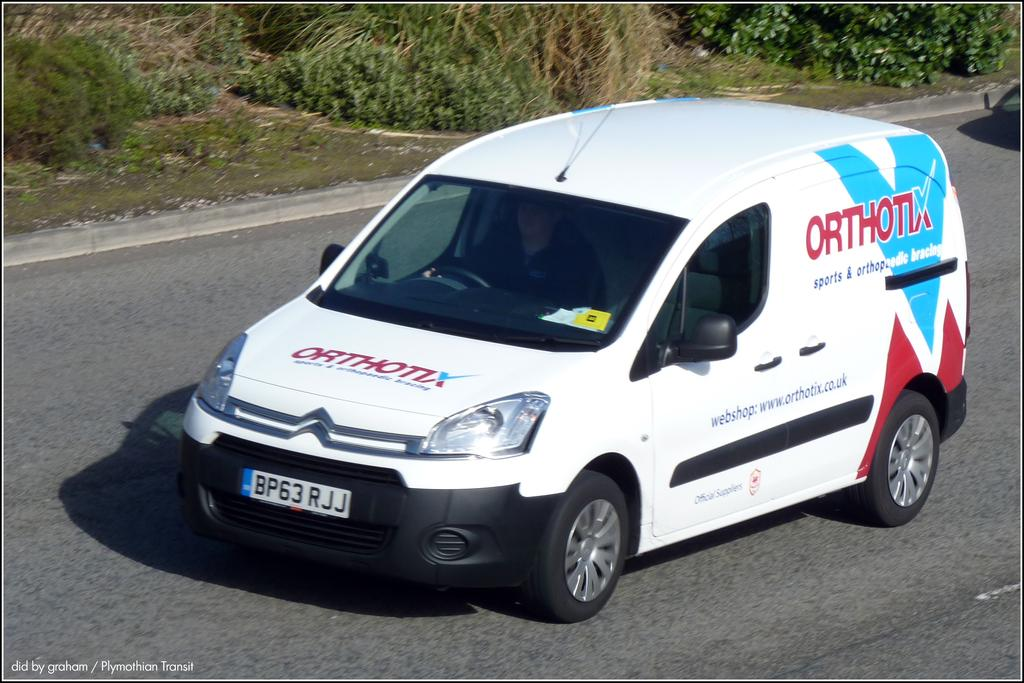Provide a one-sentence caption for the provided image. A company van has the business name Orthotix on its hood and side. 